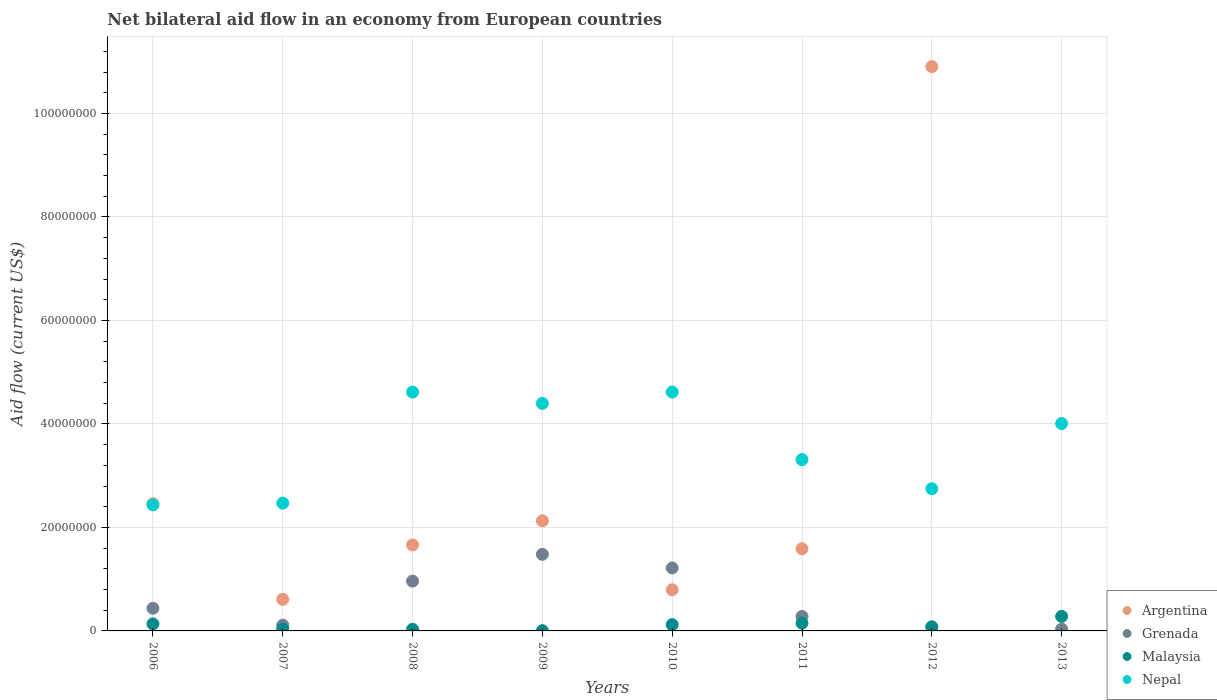Is the number of dotlines equal to the number of legend labels?
Your response must be concise. No. What is the net bilateral aid flow in Malaysia in 2013?
Keep it short and to the point. 2.81e+06. Across all years, what is the maximum net bilateral aid flow in Malaysia?
Ensure brevity in your answer.  2.81e+06. Across all years, what is the minimum net bilateral aid flow in Malaysia?
Keep it short and to the point. 5.00e+04. What is the total net bilateral aid flow in Malaysia in the graph?
Make the answer very short. 8.37e+06. What is the difference between the net bilateral aid flow in Nepal in 2007 and that in 2010?
Your answer should be very brief. -2.15e+07. What is the difference between the net bilateral aid flow in Malaysia in 2013 and the net bilateral aid flow in Argentina in 2007?
Keep it short and to the point. -3.29e+06. What is the average net bilateral aid flow in Argentina per year?
Provide a succinct answer. 2.52e+07. In the year 2010, what is the difference between the net bilateral aid flow in Grenada and net bilateral aid flow in Argentina?
Ensure brevity in your answer.  4.21e+06. In how many years, is the net bilateral aid flow in Grenada greater than 64000000 US$?
Your answer should be very brief. 0. What is the ratio of the net bilateral aid flow in Malaysia in 2008 to that in 2012?
Provide a short and direct response. 0.41. What is the difference between the highest and the second highest net bilateral aid flow in Malaysia?
Offer a very short reply. 1.31e+06. What is the difference between the highest and the lowest net bilateral aid flow in Grenada?
Your answer should be very brief. 1.45e+07. In how many years, is the net bilateral aid flow in Nepal greater than the average net bilateral aid flow in Nepal taken over all years?
Offer a very short reply. 4. Is it the case that in every year, the sum of the net bilateral aid flow in Nepal and net bilateral aid flow in Argentina  is greater than the sum of net bilateral aid flow in Malaysia and net bilateral aid flow in Grenada?
Your answer should be very brief. No. Is it the case that in every year, the sum of the net bilateral aid flow in Nepal and net bilateral aid flow in Argentina  is greater than the net bilateral aid flow in Grenada?
Your answer should be compact. Yes. Does the net bilateral aid flow in Nepal monotonically increase over the years?
Ensure brevity in your answer.  No. Is the net bilateral aid flow in Nepal strictly less than the net bilateral aid flow in Argentina over the years?
Provide a short and direct response. No. How many dotlines are there?
Provide a short and direct response. 4. Are the values on the major ticks of Y-axis written in scientific E-notation?
Keep it short and to the point. No. Does the graph contain any zero values?
Keep it short and to the point. Yes. Where does the legend appear in the graph?
Your response must be concise. Bottom right. How are the legend labels stacked?
Offer a terse response. Vertical. What is the title of the graph?
Your response must be concise. Net bilateral aid flow in an economy from European countries. Does "Afghanistan" appear as one of the legend labels in the graph?
Provide a short and direct response. No. What is the Aid flow (current US$) of Argentina in 2006?
Your answer should be very brief. 2.46e+07. What is the Aid flow (current US$) of Grenada in 2006?
Provide a short and direct response. 4.38e+06. What is the Aid flow (current US$) of Malaysia in 2006?
Give a very brief answer. 1.36e+06. What is the Aid flow (current US$) in Nepal in 2006?
Your answer should be compact. 2.44e+07. What is the Aid flow (current US$) in Argentina in 2007?
Your response must be concise. 6.10e+06. What is the Aid flow (current US$) of Grenada in 2007?
Make the answer very short. 1.11e+06. What is the Aid flow (current US$) in Nepal in 2007?
Provide a succinct answer. 2.47e+07. What is the Aid flow (current US$) in Argentina in 2008?
Make the answer very short. 1.66e+07. What is the Aid flow (current US$) of Grenada in 2008?
Ensure brevity in your answer.  9.63e+06. What is the Aid flow (current US$) in Malaysia in 2008?
Give a very brief answer. 3.10e+05. What is the Aid flow (current US$) in Nepal in 2008?
Your response must be concise. 4.62e+07. What is the Aid flow (current US$) in Argentina in 2009?
Your answer should be very brief. 2.13e+07. What is the Aid flow (current US$) of Grenada in 2009?
Your response must be concise. 1.48e+07. What is the Aid flow (current US$) in Nepal in 2009?
Your answer should be compact. 4.40e+07. What is the Aid flow (current US$) in Argentina in 2010?
Make the answer very short. 7.96e+06. What is the Aid flow (current US$) of Grenada in 2010?
Ensure brevity in your answer.  1.22e+07. What is the Aid flow (current US$) in Malaysia in 2010?
Ensure brevity in your answer.  1.21e+06. What is the Aid flow (current US$) in Nepal in 2010?
Your answer should be very brief. 4.62e+07. What is the Aid flow (current US$) of Argentina in 2011?
Make the answer very short. 1.59e+07. What is the Aid flow (current US$) of Grenada in 2011?
Ensure brevity in your answer.  2.79e+06. What is the Aid flow (current US$) in Malaysia in 2011?
Provide a short and direct response. 1.50e+06. What is the Aid flow (current US$) in Nepal in 2011?
Keep it short and to the point. 3.31e+07. What is the Aid flow (current US$) of Argentina in 2012?
Your response must be concise. 1.09e+08. What is the Aid flow (current US$) of Grenada in 2012?
Offer a very short reply. 8.00e+05. What is the Aid flow (current US$) in Malaysia in 2012?
Offer a very short reply. 7.50e+05. What is the Aid flow (current US$) in Nepal in 2012?
Provide a succinct answer. 2.75e+07. What is the Aid flow (current US$) in Argentina in 2013?
Make the answer very short. 0. What is the Aid flow (current US$) in Grenada in 2013?
Ensure brevity in your answer.  3.40e+05. What is the Aid flow (current US$) in Malaysia in 2013?
Your answer should be compact. 2.81e+06. What is the Aid flow (current US$) in Nepal in 2013?
Provide a succinct answer. 4.01e+07. Across all years, what is the maximum Aid flow (current US$) of Argentina?
Keep it short and to the point. 1.09e+08. Across all years, what is the maximum Aid flow (current US$) in Grenada?
Your response must be concise. 1.48e+07. Across all years, what is the maximum Aid flow (current US$) of Malaysia?
Give a very brief answer. 2.81e+06. Across all years, what is the maximum Aid flow (current US$) of Nepal?
Give a very brief answer. 4.62e+07. Across all years, what is the minimum Aid flow (current US$) in Grenada?
Provide a succinct answer. 3.40e+05. Across all years, what is the minimum Aid flow (current US$) in Nepal?
Provide a short and direct response. 2.44e+07. What is the total Aid flow (current US$) of Argentina in the graph?
Offer a terse response. 2.01e+08. What is the total Aid flow (current US$) of Grenada in the graph?
Provide a short and direct response. 4.60e+07. What is the total Aid flow (current US$) of Malaysia in the graph?
Keep it short and to the point. 8.37e+06. What is the total Aid flow (current US$) of Nepal in the graph?
Your response must be concise. 2.86e+08. What is the difference between the Aid flow (current US$) of Argentina in 2006 and that in 2007?
Keep it short and to the point. 1.85e+07. What is the difference between the Aid flow (current US$) in Grenada in 2006 and that in 2007?
Offer a terse response. 3.27e+06. What is the difference between the Aid flow (current US$) of Malaysia in 2006 and that in 2007?
Provide a short and direct response. 9.80e+05. What is the difference between the Aid flow (current US$) of Nepal in 2006 and that in 2007?
Your answer should be very brief. -3.30e+05. What is the difference between the Aid flow (current US$) in Argentina in 2006 and that in 2008?
Your response must be concise. 7.97e+06. What is the difference between the Aid flow (current US$) of Grenada in 2006 and that in 2008?
Make the answer very short. -5.25e+06. What is the difference between the Aid flow (current US$) in Malaysia in 2006 and that in 2008?
Offer a terse response. 1.05e+06. What is the difference between the Aid flow (current US$) in Nepal in 2006 and that in 2008?
Your answer should be very brief. -2.18e+07. What is the difference between the Aid flow (current US$) of Argentina in 2006 and that in 2009?
Your response must be concise. 3.30e+06. What is the difference between the Aid flow (current US$) in Grenada in 2006 and that in 2009?
Make the answer very short. -1.04e+07. What is the difference between the Aid flow (current US$) in Malaysia in 2006 and that in 2009?
Give a very brief answer. 1.31e+06. What is the difference between the Aid flow (current US$) of Nepal in 2006 and that in 2009?
Your answer should be compact. -1.96e+07. What is the difference between the Aid flow (current US$) in Argentina in 2006 and that in 2010?
Offer a very short reply. 1.66e+07. What is the difference between the Aid flow (current US$) of Grenada in 2006 and that in 2010?
Your answer should be very brief. -7.79e+06. What is the difference between the Aid flow (current US$) of Malaysia in 2006 and that in 2010?
Ensure brevity in your answer.  1.50e+05. What is the difference between the Aid flow (current US$) of Nepal in 2006 and that in 2010?
Your response must be concise. -2.18e+07. What is the difference between the Aid flow (current US$) in Argentina in 2006 and that in 2011?
Ensure brevity in your answer.  8.70e+06. What is the difference between the Aid flow (current US$) in Grenada in 2006 and that in 2011?
Offer a terse response. 1.59e+06. What is the difference between the Aid flow (current US$) in Nepal in 2006 and that in 2011?
Make the answer very short. -8.74e+06. What is the difference between the Aid flow (current US$) of Argentina in 2006 and that in 2012?
Give a very brief answer. -8.45e+07. What is the difference between the Aid flow (current US$) in Grenada in 2006 and that in 2012?
Provide a short and direct response. 3.58e+06. What is the difference between the Aid flow (current US$) in Nepal in 2006 and that in 2012?
Offer a terse response. -3.11e+06. What is the difference between the Aid flow (current US$) in Grenada in 2006 and that in 2013?
Your answer should be very brief. 4.04e+06. What is the difference between the Aid flow (current US$) in Malaysia in 2006 and that in 2013?
Your response must be concise. -1.45e+06. What is the difference between the Aid flow (current US$) of Nepal in 2006 and that in 2013?
Your response must be concise. -1.57e+07. What is the difference between the Aid flow (current US$) in Argentina in 2007 and that in 2008?
Make the answer very short. -1.05e+07. What is the difference between the Aid flow (current US$) in Grenada in 2007 and that in 2008?
Offer a very short reply. -8.52e+06. What is the difference between the Aid flow (current US$) of Nepal in 2007 and that in 2008?
Offer a terse response. -2.15e+07. What is the difference between the Aid flow (current US$) of Argentina in 2007 and that in 2009?
Your answer should be very brief. -1.52e+07. What is the difference between the Aid flow (current US$) of Grenada in 2007 and that in 2009?
Your response must be concise. -1.37e+07. What is the difference between the Aid flow (current US$) of Nepal in 2007 and that in 2009?
Provide a succinct answer. -1.93e+07. What is the difference between the Aid flow (current US$) of Argentina in 2007 and that in 2010?
Provide a succinct answer. -1.86e+06. What is the difference between the Aid flow (current US$) in Grenada in 2007 and that in 2010?
Provide a short and direct response. -1.11e+07. What is the difference between the Aid flow (current US$) in Malaysia in 2007 and that in 2010?
Give a very brief answer. -8.30e+05. What is the difference between the Aid flow (current US$) in Nepal in 2007 and that in 2010?
Your answer should be very brief. -2.15e+07. What is the difference between the Aid flow (current US$) in Argentina in 2007 and that in 2011?
Make the answer very short. -9.78e+06. What is the difference between the Aid flow (current US$) of Grenada in 2007 and that in 2011?
Your answer should be compact. -1.68e+06. What is the difference between the Aid flow (current US$) in Malaysia in 2007 and that in 2011?
Offer a very short reply. -1.12e+06. What is the difference between the Aid flow (current US$) in Nepal in 2007 and that in 2011?
Offer a terse response. -8.41e+06. What is the difference between the Aid flow (current US$) in Argentina in 2007 and that in 2012?
Offer a very short reply. -1.03e+08. What is the difference between the Aid flow (current US$) of Grenada in 2007 and that in 2012?
Your answer should be compact. 3.10e+05. What is the difference between the Aid flow (current US$) of Malaysia in 2007 and that in 2012?
Offer a terse response. -3.70e+05. What is the difference between the Aid flow (current US$) in Nepal in 2007 and that in 2012?
Keep it short and to the point. -2.78e+06. What is the difference between the Aid flow (current US$) in Grenada in 2007 and that in 2013?
Give a very brief answer. 7.70e+05. What is the difference between the Aid flow (current US$) of Malaysia in 2007 and that in 2013?
Ensure brevity in your answer.  -2.43e+06. What is the difference between the Aid flow (current US$) of Nepal in 2007 and that in 2013?
Ensure brevity in your answer.  -1.54e+07. What is the difference between the Aid flow (current US$) in Argentina in 2008 and that in 2009?
Your answer should be very brief. -4.67e+06. What is the difference between the Aid flow (current US$) in Grenada in 2008 and that in 2009?
Offer a very short reply. -5.17e+06. What is the difference between the Aid flow (current US$) in Malaysia in 2008 and that in 2009?
Provide a succinct answer. 2.60e+05. What is the difference between the Aid flow (current US$) in Nepal in 2008 and that in 2009?
Your response must be concise. 2.18e+06. What is the difference between the Aid flow (current US$) in Argentina in 2008 and that in 2010?
Your answer should be very brief. 8.65e+06. What is the difference between the Aid flow (current US$) in Grenada in 2008 and that in 2010?
Give a very brief answer. -2.54e+06. What is the difference between the Aid flow (current US$) in Malaysia in 2008 and that in 2010?
Keep it short and to the point. -9.00e+05. What is the difference between the Aid flow (current US$) in Nepal in 2008 and that in 2010?
Keep it short and to the point. 0. What is the difference between the Aid flow (current US$) of Argentina in 2008 and that in 2011?
Provide a succinct answer. 7.30e+05. What is the difference between the Aid flow (current US$) of Grenada in 2008 and that in 2011?
Your answer should be very brief. 6.84e+06. What is the difference between the Aid flow (current US$) of Malaysia in 2008 and that in 2011?
Provide a short and direct response. -1.19e+06. What is the difference between the Aid flow (current US$) in Nepal in 2008 and that in 2011?
Offer a terse response. 1.30e+07. What is the difference between the Aid flow (current US$) of Argentina in 2008 and that in 2012?
Your answer should be very brief. -9.24e+07. What is the difference between the Aid flow (current US$) in Grenada in 2008 and that in 2012?
Give a very brief answer. 8.83e+06. What is the difference between the Aid flow (current US$) in Malaysia in 2008 and that in 2012?
Provide a succinct answer. -4.40e+05. What is the difference between the Aid flow (current US$) of Nepal in 2008 and that in 2012?
Ensure brevity in your answer.  1.87e+07. What is the difference between the Aid flow (current US$) of Grenada in 2008 and that in 2013?
Your answer should be compact. 9.29e+06. What is the difference between the Aid flow (current US$) of Malaysia in 2008 and that in 2013?
Your response must be concise. -2.50e+06. What is the difference between the Aid flow (current US$) of Nepal in 2008 and that in 2013?
Ensure brevity in your answer.  6.08e+06. What is the difference between the Aid flow (current US$) in Argentina in 2009 and that in 2010?
Your answer should be very brief. 1.33e+07. What is the difference between the Aid flow (current US$) in Grenada in 2009 and that in 2010?
Your response must be concise. 2.63e+06. What is the difference between the Aid flow (current US$) in Malaysia in 2009 and that in 2010?
Your response must be concise. -1.16e+06. What is the difference between the Aid flow (current US$) of Nepal in 2009 and that in 2010?
Make the answer very short. -2.18e+06. What is the difference between the Aid flow (current US$) of Argentina in 2009 and that in 2011?
Your answer should be compact. 5.40e+06. What is the difference between the Aid flow (current US$) of Grenada in 2009 and that in 2011?
Offer a very short reply. 1.20e+07. What is the difference between the Aid flow (current US$) in Malaysia in 2009 and that in 2011?
Your answer should be compact. -1.45e+06. What is the difference between the Aid flow (current US$) of Nepal in 2009 and that in 2011?
Your answer should be compact. 1.09e+07. What is the difference between the Aid flow (current US$) in Argentina in 2009 and that in 2012?
Offer a very short reply. -8.78e+07. What is the difference between the Aid flow (current US$) in Grenada in 2009 and that in 2012?
Give a very brief answer. 1.40e+07. What is the difference between the Aid flow (current US$) of Malaysia in 2009 and that in 2012?
Provide a succinct answer. -7.00e+05. What is the difference between the Aid flow (current US$) of Nepal in 2009 and that in 2012?
Provide a short and direct response. 1.65e+07. What is the difference between the Aid flow (current US$) in Grenada in 2009 and that in 2013?
Ensure brevity in your answer.  1.45e+07. What is the difference between the Aid flow (current US$) in Malaysia in 2009 and that in 2013?
Your answer should be very brief. -2.76e+06. What is the difference between the Aid flow (current US$) in Nepal in 2009 and that in 2013?
Offer a very short reply. 3.90e+06. What is the difference between the Aid flow (current US$) of Argentina in 2010 and that in 2011?
Provide a succinct answer. -7.92e+06. What is the difference between the Aid flow (current US$) in Grenada in 2010 and that in 2011?
Make the answer very short. 9.38e+06. What is the difference between the Aid flow (current US$) in Nepal in 2010 and that in 2011?
Offer a very short reply. 1.30e+07. What is the difference between the Aid flow (current US$) in Argentina in 2010 and that in 2012?
Provide a short and direct response. -1.01e+08. What is the difference between the Aid flow (current US$) in Grenada in 2010 and that in 2012?
Offer a terse response. 1.14e+07. What is the difference between the Aid flow (current US$) in Nepal in 2010 and that in 2012?
Keep it short and to the point. 1.87e+07. What is the difference between the Aid flow (current US$) of Grenada in 2010 and that in 2013?
Keep it short and to the point. 1.18e+07. What is the difference between the Aid flow (current US$) in Malaysia in 2010 and that in 2013?
Your answer should be compact. -1.60e+06. What is the difference between the Aid flow (current US$) of Nepal in 2010 and that in 2013?
Give a very brief answer. 6.08e+06. What is the difference between the Aid flow (current US$) in Argentina in 2011 and that in 2012?
Offer a very short reply. -9.32e+07. What is the difference between the Aid flow (current US$) of Grenada in 2011 and that in 2012?
Make the answer very short. 1.99e+06. What is the difference between the Aid flow (current US$) in Malaysia in 2011 and that in 2012?
Keep it short and to the point. 7.50e+05. What is the difference between the Aid flow (current US$) of Nepal in 2011 and that in 2012?
Provide a succinct answer. 5.63e+06. What is the difference between the Aid flow (current US$) in Grenada in 2011 and that in 2013?
Offer a very short reply. 2.45e+06. What is the difference between the Aid flow (current US$) of Malaysia in 2011 and that in 2013?
Give a very brief answer. -1.31e+06. What is the difference between the Aid flow (current US$) in Nepal in 2011 and that in 2013?
Give a very brief answer. -6.97e+06. What is the difference between the Aid flow (current US$) in Grenada in 2012 and that in 2013?
Your answer should be compact. 4.60e+05. What is the difference between the Aid flow (current US$) of Malaysia in 2012 and that in 2013?
Provide a succinct answer. -2.06e+06. What is the difference between the Aid flow (current US$) in Nepal in 2012 and that in 2013?
Your answer should be very brief. -1.26e+07. What is the difference between the Aid flow (current US$) in Argentina in 2006 and the Aid flow (current US$) in Grenada in 2007?
Offer a very short reply. 2.35e+07. What is the difference between the Aid flow (current US$) in Argentina in 2006 and the Aid flow (current US$) in Malaysia in 2007?
Give a very brief answer. 2.42e+07. What is the difference between the Aid flow (current US$) in Grenada in 2006 and the Aid flow (current US$) in Nepal in 2007?
Provide a succinct answer. -2.03e+07. What is the difference between the Aid flow (current US$) in Malaysia in 2006 and the Aid flow (current US$) in Nepal in 2007?
Your response must be concise. -2.33e+07. What is the difference between the Aid flow (current US$) of Argentina in 2006 and the Aid flow (current US$) of Grenada in 2008?
Keep it short and to the point. 1.50e+07. What is the difference between the Aid flow (current US$) in Argentina in 2006 and the Aid flow (current US$) in Malaysia in 2008?
Offer a terse response. 2.43e+07. What is the difference between the Aid flow (current US$) of Argentina in 2006 and the Aid flow (current US$) of Nepal in 2008?
Make the answer very short. -2.16e+07. What is the difference between the Aid flow (current US$) of Grenada in 2006 and the Aid flow (current US$) of Malaysia in 2008?
Your answer should be compact. 4.07e+06. What is the difference between the Aid flow (current US$) in Grenada in 2006 and the Aid flow (current US$) in Nepal in 2008?
Give a very brief answer. -4.18e+07. What is the difference between the Aid flow (current US$) in Malaysia in 2006 and the Aid flow (current US$) in Nepal in 2008?
Keep it short and to the point. -4.48e+07. What is the difference between the Aid flow (current US$) of Argentina in 2006 and the Aid flow (current US$) of Grenada in 2009?
Provide a succinct answer. 9.78e+06. What is the difference between the Aid flow (current US$) in Argentina in 2006 and the Aid flow (current US$) in Malaysia in 2009?
Offer a terse response. 2.45e+07. What is the difference between the Aid flow (current US$) in Argentina in 2006 and the Aid flow (current US$) in Nepal in 2009?
Your response must be concise. -1.94e+07. What is the difference between the Aid flow (current US$) of Grenada in 2006 and the Aid flow (current US$) of Malaysia in 2009?
Provide a succinct answer. 4.33e+06. What is the difference between the Aid flow (current US$) in Grenada in 2006 and the Aid flow (current US$) in Nepal in 2009?
Your response must be concise. -3.96e+07. What is the difference between the Aid flow (current US$) in Malaysia in 2006 and the Aid flow (current US$) in Nepal in 2009?
Your response must be concise. -4.26e+07. What is the difference between the Aid flow (current US$) in Argentina in 2006 and the Aid flow (current US$) in Grenada in 2010?
Provide a short and direct response. 1.24e+07. What is the difference between the Aid flow (current US$) in Argentina in 2006 and the Aid flow (current US$) in Malaysia in 2010?
Provide a succinct answer. 2.34e+07. What is the difference between the Aid flow (current US$) in Argentina in 2006 and the Aid flow (current US$) in Nepal in 2010?
Provide a short and direct response. -2.16e+07. What is the difference between the Aid flow (current US$) of Grenada in 2006 and the Aid flow (current US$) of Malaysia in 2010?
Offer a very short reply. 3.17e+06. What is the difference between the Aid flow (current US$) of Grenada in 2006 and the Aid flow (current US$) of Nepal in 2010?
Offer a very short reply. -4.18e+07. What is the difference between the Aid flow (current US$) of Malaysia in 2006 and the Aid flow (current US$) of Nepal in 2010?
Make the answer very short. -4.48e+07. What is the difference between the Aid flow (current US$) in Argentina in 2006 and the Aid flow (current US$) in Grenada in 2011?
Provide a succinct answer. 2.18e+07. What is the difference between the Aid flow (current US$) of Argentina in 2006 and the Aid flow (current US$) of Malaysia in 2011?
Provide a short and direct response. 2.31e+07. What is the difference between the Aid flow (current US$) of Argentina in 2006 and the Aid flow (current US$) of Nepal in 2011?
Make the answer very short. -8.53e+06. What is the difference between the Aid flow (current US$) in Grenada in 2006 and the Aid flow (current US$) in Malaysia in 2011?
Provide a short and direct response. 2.88e+06. What is the difference between the Aid flow (current US$) of Grenada in 2006 and the Aid flow (current US$) of Nepal in 2011?
Keep it short and to the point. -2.87e+07. What is the difference between the Aid flow (current US$) of Malaysia in 2006 and the Aid flow (current US$) of Nepal in 2011?
Your answer should be compact. -3.18e+07. What is the difference between the Aid flow (current US$) in Argentina in 2006 and the Aid flow (current US$) in Grenada in 2012?
Ensure brevity in your answer.  2.38e+07. What is the difference between the Aid flow (current US$) in Argentina in 2006 and the Aid flow (current US$) in Malaysia in 2012?
Your response must be concise. 2.38e+07. What is the difference between the Aid flow (current US$) of Argentina in 2006 and the Aid flow (current US$) of Nepal in 2012?
Provide a short and direct response. -2.90e+06. What is the difference between the Aid flow (current US$) of Grenada in 2006 and the Aid flow (current US$) of Malaysia in 2012?
Provide a short and direct response. 3.63e+06. What is the difference between the Aid flow (current US$) of Grenada in 2006 and the Aid flow (current US$) of Nepal in 2012?
Your response must be concise. -2.31e+07. What is the difference between the Aid flow (current US$) in Malaysia in 2006 and the Aid flow (current US$) in Nepal in 2012?
Ensure brevity in your answer.  -2.61e+07. What is the difference between the Aid flow (current US$) in Argentina in 2006 and the Aid flow (current US$) in Grenada in 2013?
Your response must be concise. 2.42e+07. What is the difference between the Aid flow (current US$) of Argentina in 2006 and the Aid flow (current US$) of Malaysia in 2013?
Your answer should be compact. 2.18e+07. What is the difference between the Aid flow (current US$) of Argentina in 2006 and the Aid flow (current US$) of Nepal in 2013?
Provide a succinct answer. -1.55e+07. What is the difference between the Aid flow (current US$) of Grenada in 2006 and the Aid flow (current US$) of Malaysia in 2013?
Keep it short and to the point. 1.57e+06. What is the difference between the Aid flow (current US$) of Grenada in 2006 and the Aid flow (current US$) of Nepal in 2013?
Provide a short and direct response. -3.57e+07. What is the difference between the Aid flow (current US$) in Malaysia in 2006 and the Aid flow (current US$) in Nepal in 2013?
Give a very brief answer. -3.87e+07. What is the difference between the Aid flow (current US$) of Argentina in 2007 and the Aid flow (current US$) of Grenada in 2008?
Provide a short and direct response. -3.53e+06. What is the difference between the Aid flow (current US$) of Argentina in 2007 and the Aid flow (current US$) of Malaysia in 2008?
Give a very brief answer. 5.79e+06. What is the difference between the Aid flow (current US$) in Argentina in 2007 and the Aid flow (current US$) in Nepal in 2008?
Provide a succinct answer. -4.01e+07. What is the difference between the Aid flow (current US$) in Grenada in 2007 and the Aid flow (current US$) in Nepal in 2008?
Provide a short and direct response. -4.50e+07. What is the difference between the Aid flow (current US$) of Malaysia in 2007 and the Aid flow (current US$) of Nepal in 2008?
Make the answer very short. -4.58e+07. What is the difference between the Aid flow (current US$) of Argentina in 2007 and the Aid flow (current US$) of Grenada in 2009?
Offer a terse response. -8.70e+06. What is the difference between the Aid flow (current US$) of Argentina in 2007 and the Aid flow (current US$) of Malaysia in 2009?
Offer a terse response. 6.05e+06. What is the difference between the Aid flow (current US$) in Argentina in 2007 and the Aid flow (current US$) in Nepal in 2009?
Provide a succinct answer. -3.79e+07. What is the difference between the Aid flow (current US$) in Grenada in 2007 and the Aid flow (current US$) in Malaysia in 2009?
Keep it short and to the point. 1.06e+06. What is the difference between the Aid flow (current US$) of Grenada in 2007 and the Aid flow (current US$) of Nepal in 2009?
Your response must be concise. -4.29e+07. What is the difference between the Aid flow (current US$) in Malaysia in 2007 and the Aid flow (current US$) in Nepal in 2009?
Make the answer very short. -4.36e+07. What is the difference between the Aid flow (current US$) in Argentina in 2007 and the Aid flow (current US$) in Grenada in 2010?
Give a very brief answer. -6.07e+06. What is the difference between the Aid flow (current US$) of Argentina in 2007 and the Aid flow (current US$) of Malaysia in 2010?
Give a very brief answer. 4.89e+06. What is the difference between the Aid flow (current US$) of Argentina in 2007 and the Aid flow (current US$) of Nepal in 2010?
Make the answer very short. -4.01e+07. What is the difference between the Aid flow (current US$) in Grenada in 2007 and the Aid flow (current US$) in Malaysia in 2010?
Provide a short and direct response. -1.00e+05. What is the difference between the Aid flow (current US$) of Grenada in 2007 and the Aid flow (current US$) of Nepal in 2010?
Provide a short and direct response. -4.50e+07. What is the difference between the Aid flow (current US$) of Malaysia in 2007 and the Aid flow (current US$) of Nepal in 2010?
Offer a very short reply. -4.58e+07. What is the difference between the Aid flow (current US$) in Argentina in 2007 and the Aid flow (current US$) in Grenada in 2011?
Give a very brief answer. 3.31e+06. What is the difference between the Aid flow (current US$) of Argentina in 2007 and the Aid flow (current US$) of Malaysia in 2011?
Your response must be concise. 4.60e+06. What is the difference between the Aid flow (current US$) in Argentina in 2007 and the Aid flow (current US$) in Nepal in 2011?
Your response must be concise. -2.70e+07. What is the difference between the Aid flow (current US$) in Grenada in 2007 and the Aid flow (current US$) in Malaysia in 2011?
Offer a terse response. -3.90e+05. What is the difference between the Aid flow (current US$) in Grenada in 2007 and the Aid flow (current US$) in Nepal in 2011?
Make the answer very short. -3.20e+07. What is the difference between the Aid flow (current US$) of Malaysia in 2007 and the Aid flow (current US$) of Nepal in 2011?
Make the answer very short. -3.27e+07. What is the difference between the Aid flow (current US$) of Argentina in 2007 and the Aid flow (current US$) of Grenada in 2012?
Your answer should be very brief. 5.30e+06. What is the difference between the Aid flow (current US$) in Argentina in 2007 and the Aid flow (current US$) in Malaysia in 2012?
Ensure brevity in your answer.  5.35e+06. What is the difference between the Aid flow (current US$) of Argentina in 2007 and the Aid flow (current US$) of Nepal in 2012?
Offer a terse response. -2.14e+07. What is the difference between the Aid flow (current US$) of Grenada in 2007 and the Aid flow (current US$) of Malaysia in 2012?
Make the answer very short. 3.60e+05. What is the difference between the Aid flow (current US$) in Grenada in 2007 and the Aid flow (current US$) in Nepal in 2012?
Offer a terse response. -2.64e+07. What is the difference between the Aid flow (current US$) of Malaysia in 2007 and the Aid flow (current US$) of Nepal in 2012?
Provide a succinct answer. -2.71e+07. What is the difference between the Aid flow (current US$) in Argentina in 2007 and the Aid flow (current US$) in Grenada in 2013?
Offer a terse response. 5.76e+06. What is the difference between the Aid flow (current US$) of Argentina in 2007 and the Aid flow (current US$) of Malaysia in 2013?
Offer a terse response. 3.29e+06. What is the difference between the Aid flow (current US$) of Argentina in 2007 and the Aid flow (current US$) of Nepal in 2013?
Offer a terse response. -3.40e+07. What is the difference between the Aid flow (current US$) in Grenada in 2007 and the Aid flow (current US$) in Malaysia in 2013?
Give a very brief answer. -1.70e+06. What is the difference between the Aid flow (current US$) in Grenada in 2007 and the Aid flow (current US$) in Nepal in 2013?
Provide a short and direct response. -3.90e+07. What is the difference between the Aid flow (current US$) of Malaysia in 2007 and the Aid flow (current US$) of Nepal in 2013?
Offer a very short reply. -3.97e+07. What is the difference between the Aid flow (current US$) of Argentina in 2008 and the Aid flow (current US$) of Grenada in 2009?
Make the answer very short. 1.81e+06. What is the difference between the Aid flow (current US$) of Argentina in 2008 and the Aid flow (current US$) of Malaysia in 2009?
Give a very brief answer. 1.66e+07. What is the difference between the Aid flow (current US$) of Argentina in 2008 and the Aid flow (current US$) of Nepal in 2009?
Your answer should be compact. -2.74e+07. What is the difference between the Aid flow (current US$) of Grenada in 2008 and the Aid flow (current US$) of Malaysia in 2009?
Offer a very short reply. 9.58e+06. What is the difference between the Aid flow (current US$) of Grenada in 2008 and the Aid flow (current US$) of Nepal in 2009?
Keep it short and to the point. -3.44e+07. What is the difference between the Aid flow (current US$) of Malaysia in 2008 and the Aid flow (current US$) of Nepal in 2009?
Provide a succinct answer. -4.37e+07. What is the difference between the Aid flow (current US$) in Argentina in 2008 and the Aid flow (current US$) in Grenada in 2010?
Provide a short and direct response. 4.44e+06. What is the difference between the Aid flow (current US$) in Argentina in 2008 and the Aid flow (current US$) in Malaysia in 2010?
Ensure brevity in your answer.  1.54e+07. What is the difference between the Aid flow (current US$) of Argentina in 2008 and the Aid flow (current US$) of Nepal in 2010?
Provide a succinct answer. -2.96e+07. What is the difference between the Aid flow (current US$) of Grenada in 2008 and the Aid flow (current US$) of Malaysia in 2010?
Your answer should be compact. 8.42e+06. What is the difference between the Aid flow (current US$) of Grenada in 2008 and the Aid flow (current US$) of Nepal in 2010?
Offer a terse response. -3.65e+07. What is the difference between the Aid flow (current US$) of Malaysia in 2008 and the Aid flow (current US$) of Nepal in 2010?
Your answer should be compact. -4.58e+07. What is the difference between the Aid flow (current US$) in Argentina in 2008 and the Aid flow (current US$) in Grenada in 2011?
Keep it short and to the point. 1.38e+07. What is the difference between the Aid flow (current US$) in Argentina in 2008 and the Aid flow (current US$) in Malaysia in 2011?
Offer a very short reply. 1.51e+07. What is the difference between the Aid flow (current US$) in Argentina in 2008 and the Aid flow (current US$) in Nepal in 2011?
Your answer should be very brief. -1.65e+07. What is the difference between the Aid flow (current US$) in Grenada in 2008 and the Aid flow (current US$) in Malaysia in 2011?
Provide a succinct answer. 8.13e+06. What is the difference between the Aid flow (current US$) in Grenada in 2008 and the Aid flow (current US$) in Nepal in 2011?
Offer a terse response. -2.35e+07. What is the difference between the Aid flow (current US$) of Malaysia in 2008 and the Aid flow (current US$) of Nepal in 2011?
Offer a terse response. -3.28e+07. What is the difference between the Aid flow (current US$) of Argentina in 2008 and the Aid flow (current US$) of Grenada in 2012?
Provide a short and direct response. 1.58e+07. What is the difference between the Aid flow (current US$) in Argentina in 2008 and the Aid flow (current US$) in Malaysia in 2012?
Your response must be concise. 1.59e+07. What is the difference between the Aid flow (current US$) in Argentina in 2008 and the Aid flow (current US$) in Nepal in 2012?
Provide a short and direct response. -1.09e+07. What is the difference between the Aid flow (current US$) of Grenada in 2008 and the Aid flow (current US$) of Malaysia in 2012?
Ensure brevity in your answer.  8.88e+06. What is the difference between the Aid flow (current US$) in Grenada in 2008 and the Aid flow (current US$) in Nepal in 2012?
Make the answer very short. -1.78e+07. What is the difference between the Aid flow (current US$) in Malaysia in 2008 and the Aid flow (current US$) in Nepal in 2012?
Your answer should be very brief. -2.72e+07. What is the difference between the Aid flow (current US$) in Argentina in 2008 and the Aid flow (current US$) in Grenada in 2013?
Offer a terse response. 1.63e+07. What is the difference between the Aid flow (current US$) of Argentina in 2008 and the Aid flow (current US$) of Malaysia in 2013?
Offer a terse response. 1.38e+07. What is the difference between the Aid flow (current US$) of Argentina in 2008 and the Aid flow (current US$) of Nepal in 2013?
Your answer should be compact. -2.35e+07. What is the difference between the Aid flow (current US$) of Grenada in 2008 and the Aid flow (current US$) of Malaysia in 2013?
Ensure brevity in your answer.  6.82e+06. What is the difference between the Aid flow (current US$) in Grenada in 2008 and the Aid flow (current US$) in Nepal in 2013?
Give a very brief answer. -3.04e+07. What is the difference between the Aid flow (current US$) of Malaysia in 2008 and the Aid flow (current US$) of Nepal in 2013?
Your answer should be compact. -3.98e+07. What is the difference between the Aid flow (current US$) in Argentina in 2009 and the Aid flow (current US$) in Grenada in 2010?
Your answer should be very brief. 9.11e+06. What is the difference between the Aid flow (current US$) in Argentina in 2009 and the Aid flow (current US$) in Malaysia in 2010?
Provide a succinct answer. 2.01e+07. What is the difference between the Aid flow (current US$) in Argentina in 2009 and the Aid flow (current US$) in Nepal in 2010?
Make the answer very short. -2.49e+07. What is the difference between the Aid flow (current US$) in Grenada in 2009 and the Aid flow (current US$) in Malaysia in 2010?
Your answer should be very brief. 1.36e+07. What is the difference between the Aid flow (current US$) of Grenada in 2009 and the Aid flow (current US$) of Nepal in 2010?
Provide a short and direct response. -3.14e+07. What is the difference between the Aid flow (current US$) in Malaysia in 2009 and the Aid flow (current US$) in Nepal in 2010?
Provide a succinct answer. -4.61e+07. What is the difference between the Aid flow (current US$) in Argentina in 2009 and the Aid flow (current US$) in Grenada in 2011?
Keep it short and to the point. 1.85e+07. What is the difference between the Aid flow (current US$) of Argentina in 2009 and the Aid flow (current US$) of Malaysia in 2011?
Your response must be concise. 1.98e+07. What is the difference between the Aid flow (current US$) in Argentina in 2009 and the Aid flow (current US$) in Nepal in 2011?
Keep it short and to the point. -1.18e+07. What is the difference between the Aid flow (current US$) in Grenada in 2009 and the Aid flow (current US$) in Malaysia in 2011?
Offer a very short reply. 1.33e+07. What is the difference between the Aid flow (current US$) of Grenada in 2009 and the Aid flow (current US$) of Nepal in 2011?
Offer a terse response. -1.83e+07. What is the difference between the Aid flow (current US$) in Malaysia in 2009 and the Aid flow (current US$) in Nepal in 2011?
Make the answer very short. -3.31e+07. What is the difference between the Aid flow (current US$) in Argentina in 2009 and the Aid flow (current US$) in Grenada in 2012?
Ensure brevity in your answer.  2.05e+07. What is the difference between the Aid flow (current US$) in Argentina in 2009 and the Aid flow (current US$) in Malaysia in 2012?
Your response must be concise. 2.05e+07. What is the difference between the Aid flow (current US$) of Argentina in 2009 and the Aid flow (current US$) of Nepal in 2012?
Give a very brief answer. -6.20e+06. What is the difference between the Aid flow (current US$) of Grenada in 2009 and the Aid flow (current US$) of Malaysia in 2012?
Your response must be concise. 1.40e+07. What is the difference between the Aid flow (current US$) in Grenada in 2009 and the Aid flow (current US$) in Nepal in 2012?
Make the answer very short. -1.27e+07. What is the difference between the Aid flow (current US$) of Malaysia in 2009 and the Aid flow (current US$) of Nepal in 2012?
Your response must be concise. -2.74e+07. What is the difference between the Aid flow (current US$) in Argentina in 2009 and the Aid flow (current US$) in Grenada in 2013?
Provide a succinct answer. 2.09e+07. What is the difference between the Aid flow (current US$) of Argentina in 2009 and the Aid flow (current US$) of Malaysia in 2013?
Provide a succinct answer. 1.85e+07. What is the difference between the Aid flow (current US$) in Argentina in 2009 and the Aid flow (current US$) in Nepal in 2013?
Keep it short and to the point. -1.88e+07. What is the difference between the Aid flow (current US$) in Grenada in 2009 and the Aid flow (current US$) in Malaysia in 2013?
Offer a terse response. 1.20e+07. What is the difference between the Aid flow (current US$) in Grenada in 2009 and the Aid flow (current US$) in Nepal in 2013?
Provide a short and direct response. -2.53e+07. What is the difference between the Aid flow (current US$) of Malaysia in 2009 and the Aid flow (current US$) of Nepal in 2013?
Ensure brevity in your answer.  -4.00e+07. What is the difference between the Aid flow (current US$) of Argentina in 2010 and the Aid flow (current US$) of Grenada in 2011?
Ensure brevity in your answer.  5.17e+06. What is the difference between the Aid flow (current US$) in Argentina in 2010 and the Aid flow (current US$) in Malaysia in 2011?
Your answer should be very brief. 6.46e+06. What is the difference between the Aid flow (current US$) of Argentina in 2010 and the Aid flow (current US$) of Nepal in 2011?
Offer a terse response. -2.52e+07. What is the difference between the Aid flow (current US$) of Grenada in 2010 and the Aid flow (current US$) of Malaysia in 2011?
Ensure brevity in your answer.  1.07e+07. What is the difference between the Aid flow (current US$) in Grenada in 2010 and the Aid flow (current US$) in Nepal in 2011?
Your response must be concise. -2.09e+07. What is the difference between the Aid flow (current US$) in Malaysia in 2010 and the Aid flow (current US$) in Nepal in 2011?
Provide a short and direct response. -3.19e+07. What is the difference between the Aid flow (current US$) of Argentina in 2010 and the Aid flow (current US$) of Grenada in 2012?
Provide a succinct answer. 7.16e+06. What is the difference between the Aid flow (current US$) in Argentina in 2010 and the Aid flow (current US$) in Malaysia in 2012?
Keep it short and to the point. 7.21e+06. What is the difference between the Aid flow (current US$) in Argentina in 2010 and the Aid flow (current US$) in Nepal in 2012?
Ensure brevity in your answer.  -1.95e+07. What is the difference between the Aid flow (current US$) in Grenada in 2010 and the Aid flow (current US$) in Malaysia in 2012?
Ensure brevity in your answer.  1.14e+07. What is the difference between the Aid flow (current US$) in Grenada in 2010 and the Aid flow (current US$) in Nepal in 2012?
Your response must be concise. -1.53e+07. What is the difference between the Aid flow (current US$) in Malaysia in 2010 and the Aid flow (current US$) in Nepal in 2012?
Provide a succinct answer. -2.63e+07. What is the difference between the Aid flow (current US$) in Argentina in 2010 and the Aid flow (current US$) in Grenada in 2013?
Ensure brevity in your answer.  7.62e+06. What is the difference between the Aid flow (current US$) of Argentina in 2010 and the Aid flow (current US$) of Malaysia in 2013?
Offer a terse response. 5.15e+06. What is the difference between the Aid flow (current US$) of Argentina in 2010 and the Aid flow (current US$) of Nepal in 2013?
Make the answer very short. -3.21e+07. What is the difference between the Aid flow (current US$) of Grenada in 2010 and the Aid flow (current US$) of Malaysia in 2013?
Provide a short and direct response. 9.36e+06. What is the difference between the Aid flow (current US$) in Grenada in 2010 and the Aid flow (current US$) in Nepal in 2013?
Provide a succinct answer. -2.79e+07. What is the difference between the Aid flow (current US$) in Malaysia in 2010 and the Aid flow (current US$) in Nepal in 2013?
Provide a short and direct response. -3.89e+07. What is the difference between the Aid flow (current US$) in Argentina in 2011 and the Aid flow (current US$) in Grenada in 2012?
Your response must be concise. 1.51e+07. What is the difference between the Aid flow (current US$) in Argentina in 2011 and the Aid flow (current US$) in Malaysia in 2012?
Provide a short and direct response. 1.51e+07. What is the difference between the Aid flow (current US$) in Argentina in 2011 and the Aid flow (current US$) in Nepal in 2012?
Make the answer very short. -1.16e+07. What is the difference between the Aid flow (current US$) of Grenada in 2011 and the Aid flow (current US$) of Malaysia in 2012?
Your response must be concise. 2.04e+06. What is the difference between the Aid flow (current US$) in Grenada in 2011 and the Aid flow (current US$) in Nepal in 2012?
Give a very brief answer. -2.47e+07. What is the difference between the Aid flow (current US$) in Malaysia in 2011 and the Aid flow (current US$) in Nepal in 2012?
Your answer should be very brief. -2.60e+07. What is the difference between the Aid flow (current US$) of Argentina in 2011 and the Aid flow (current US$) of Grenada in 2013?
Provide a succinct answer. 1.55e+07. What is the difference between the Aid flow (current US$) in Argentina in 2011 and the Aid flow (current US$) in Malaysia in 2013?
Your answer should be very brief. 1.31e+07. What is the difference between the Aid flow (current US$) of Argentina in 2011 and the Aid flow (current US$) of Nepal in 2013?
Make the answer very short. -2.42e+07. What is the difference between the Aid flow (current US$) of Grenada in 2011 and the Aid flow (current US$) of Malaysia in 2013?
Keep it short and to the point. -2.00e+04. What is the difference between the Aid flow (current US$) of Grenada in 2011 and the Aid flow (current US$) of Nepal in 2013?
Provide a succinct answer. -3.73e+07. What is the difference between the Aid flow (current US$) in Malaysia in 2011 and the Aid flow (current US$) in Nepal in 2013?
Ensure brevity in your answer.  -3.86e+07. What is the difference between the Aid flow (current US$) of Argentina in 2012 and the Aid flow (current US$) of Grenada in 2013?
Your response must be concise. 1.09e+08. What is the difference between the Aid flow (current US$) in Argentina in 2012 and the Aid flow (current US$) in Malaysia in 2013?
Your response must be concise. 1.06e+08. What is the difference between the Aid flow (current US$) of Argentina in 2012 and the Aid flow (current US$) of Nepal in 2013?
Provide a succinct answer. 6.90e+07. What is the difference between the Aid flow (current US$) in Grenada in 2012 and the Aid flow (current US$) in Malaysia in 2013?
Provide a succinct answer. -2.01e+06. What is the difference between the Aid flow (current US$) in Grenada in 2012 and the Aid flow (current US$) in Nepal in 2013?
Provide a succinct answer. -3.93e+07. What is the difference between the Aid flow (current US$) of Malaysia in 2012 and the Aid flow (current US$) of Nepal in 2013?
Provide a short and direct response. -3.93e+07. What is the average Aid flow (current US$) of Argentina per year?
Your answer should be very brief. 2.52e+07. What is the average Aid flow (current US$) of Grenada per year?
Provide a short and direct response. 5.75e+06. What is the average Aid flow (current US$) in Malaysia per year?
Make the answer very short. 1.05e+06. What is the average Aid flow (current US$) in Nepal per year?
Your answer should be very brief. 3.58e+07. In the year 2006, what is the difference between the Aid flow (current US$) of Argentina and Aid flow (current US$) of Grenada?
Your answer should be compact. 2.02e+07. In the year 2006, what is the difference between the Aid flow (current US$) in Argentina and Aid flow (current US$) in Malaysia?
Offer a terse response. 2.32e+07. In the year 2006, what is the difference between the Aid flow (current US$) in Argentina and Aid flow (current US$) in Nepal?
Your response must be concise. 2.10e+05. In the year 2006, what is the difference between the Aid flow (current US$) in Grenada and Aid flow (current US$) in Malaysia?
Give a very brief answer. 3.02e+06. In the year 2006, what is the difference between the Aid flow (current US$) in Grenada and Aid flow (current US$) in Nepal?
Your answer should be compact. -2.00e+07. In the year 2006, what is the difference between the Aid flow (current US$) of Malaysia and Aid flow (current US$) of Nepal?
Provide a short and direct response. -2.30e+07. In the year 2007, what is the difference between the Aid flow (current US$) in Argentina and Aid flow (current US$) in Grenada?
Your answer should be compact. 4.99e+06. In the year 2007, what is the difference between the Aid flow (current US$) in Argentina and Aid flow (current US$) in Malaysia?
Offer a very short reply. 5.72e+06. In the year 2007, what is the difference between the Aid flow (current US$) of Argentina and Aid flow (current US$) of Nepal?
Your answer should be compact. -1.86e+07. In the year 2007, what is the difference between the Aid flow (current US$) of Grenada and Aid flow (current US$) of Malaysia?
Your answer should be very brief. 7.30e+05. In the year 2007, what is the difference between the Aid flow (current US$) of Grenada and Aid flow (current US$) of Nepal?
Give a very brief answer. -2.36e+07. In the year 2007, what is the difference between the Aid flow (current US$) of Malaysia and Aid flow (current US$) of Nepal?
Keep it short and to the point. -2.43e+07. In the year 2008, what is the difference between the Aid flow (current US$) of Argentina and Aid flow (current US$) of Grenada?
Keep it short and to the point. 6.98e+06. In the year 2008, what is the difference between the Aid flow (current US$) in Argentina and Aid flow (current US$) in Malaysia?
Your answer should be compact. 1.63e+07. In the year 2008, what is the difference between the Aid flow (current US$) in Argentina and Aid flow (current US$) in Nepal?
Your response must be concise. -2.96e+07. In the year 2008, what is the difference between the Aid flow (current US$) in Grenada and Aid flow (current US$) in Malaysia?
Ensure brevity in your answer.  9.32e+06. In the year 2008, what is the difference between the Aid flow (current US$) in Grenada and Aid flow (current US$) in Nepal?
Offer a terse response. -3.65e+07. In the year 2008, what is the difference between the Aid flow (current US$) in Malaysia and Aid flow (current US$) in Nepal?
Your response must be concise. -4.58e+07. In the year 2009, what is the difference between the Aid flow (current US$) in Argentina and Aid flow (current US$) in Grenada?
Provide a succinct answer. 6.48e+06. In the year 2009, what is the difference between the Aid flow (current US$) of Argentina and Aid flow (current US$) of Malaysia?
Keep it short and to the point. 2.12e+07. In the year 2009, what is the difference between the Aid flow (current US$) in Argentina and Aid flow (current US$) in Nepal?
Your answer should be very brief. -2.27e+07. In the year 2009, what is the difference between the Aid flow (current US$) of Grenada and Aid flow (current US$) of Malaysia?
Your answer should be compact. 1.48e+07. In the year 2009, what is the difference between the Aid flow (current US$) of Grenada and Aid flow (current US$) of Nepal?
Ensure brevity in your answer.  -2.92e+07. In the year 2009, what is the difference between the Aid flow (current US$) in Malaysia and Aid flow (current US$) in Nepal?
Make the answer very short. -4.39e+07. In the year 2010, what is the difference between the Aid flow (current US$) in Argentina and Aid flow (current US$) in Grenada?
Offer a terse response. -4.21e+06. In the year 2010, what is the difference between the Aid flow (current US$) in Argentina and Aid flow (current US$) in Malaysia?
Provide a short and direct response. 6.75e+06. In the year 2010, what is the difference between the Aid flow (current US$) of Argentina and Aid flow (current US$) of Nepal?
Your response must be concise. -3.82e+07. In the year 2010, what is the difference between the Aid flow (current US$) of Grenada and Aid flow (current US$) of Malaysia?
Provide a short and direct response. 1.10e+07. In the year 2010, what is the difference between the Aid flow (current US$) in Grenada and Aid flow (current US$) in Nepal?
Provide a succinct answer. -3.40e+07. In the year 2010, what is the difference between the Aid flow (current US$) of Malaysia and Aid flow (current US$) of Nepal?
Your answer should be very brief. -4.50e+07. In the year 2011, what is the difference between the Aid flow (current US$) of Argentina and Aid flow (current US$) of Grenada?
Ensure brevity in your answer.  1.31e+07. In the year 2011, what is the difference between the Aid flow (current US$) in Argentina and Aid flow (current US$) in Malaysia?
Make the answer very short. 1.44e+07. In the year 2011, what is the difference between the Aid flow (current US$) in Argentina and Aid flow (current US$) in Nepal?
Offer a very short reply. -1.72e+07. In the year 2011, what is the difference between the Aid flow (current US$) of Grenada and Aid flow (current US$) of Malaysia?
Ensure brevity in your answer.  1.29e+06. In the year 2011, what is the difference between the Aid flow (current US$) of Grenada and Aid flow (current US$) of Nepal?
Offer a very short reply. -3.03e+07. In the year 2011, what is the difference between the Aid flow (current US$) of Malaysia and Aid flow (current US$) of Nepal?
Offer a very short reply. -3.16e+07. In the year 2012, what is the difference between the Aid flow (current US$) of Argentina and Aid flow (current US$) of Grenada?
Your response must be concise. 1.08e+08. In the year 2012, what is the difference between the Aid flow (current US$) of Argentina and Aid flow (current US$) of Malaysia?
Provide a short and direct response. 1.08e+08. In the year 2012, what is the difference between the Aid flow (current US$) in Argentina and Aid flow (current US$) in Nepal?
Provide a succinct answer. 8.16e+07. In the year 2012, what is the difference between the Aid flow (current US$) in Grenada and Aid flow (current US$) in Nepal?
Offer a very short reply. -2.67e+07. In the year 2012, what is the difference between the Aid flow (current US$) of Malaysia and Aid flow (current US$) of Nepal?
Your answer should be compact. -2.67e+07. In the year 2013, what is the difference between the Aid flow (current US$) in Grenada and Aid flow (current US$) in Malaysia?
Offer a very short reply. -2.47e+06. In the year 2013, what is the difference between the Aid flow (current US$) in Grenada and Aid flow (current US$) in Nepal?
Keep it short and to the point. -3.97e+07. In the year 2013, what is the difference between the Aid flow (current US$) of Malaysia and Aid flow (current US$) of Nepal?
Your response must be concise. -3.73e+07. What is the ratio of the Aid flow (current US$) of Argentina in 2006 to that in 2007?
Keep it short and to the point. 4.03. What is the ratio of the Aid flow (current US$) in Grenada in 2006 to that in 2007?
Provide a short and direct response. 3.95. What is the ratio of the Aid flow (current US$) in Malaysia in 2006 to that in 2007?
Offer a terse response. 3.58. What is the ratio of the Aid flow (current US$) of Nepal in 2006 to that in 2007?
Your response must be concise. 0.99. What is the ratio of the Aid flow (current US$) of Argentina in 2006 to that in 2008?
Provide a short and direct response. 1.48. What is the ratio of the Aid flow (current US$) of Grenada in 2006 to that in 2008?
Provide a succinct answer. 0.45. What is the ratio of the Aid flow (current US$) of Malaysia in 2006 to that in 2008?
Your answer should be very brief. 4.39. What is the ratio of the Aid flow (current US$) in Nepal in 2006 to that in 2008?
Your response must be concise. 0.53. What is the ratio of the Aid flow (current US$) in Argentina in 2006 to that in 2009?
Ensure brevity in your answer.  1.16. What is the ratio of the Aid flow (current US$) in Grenada in 2006 to that in 2009?
Your response must be concise. 0.3. What is the ratio of the Aid flow (current US$) of Malaysia in 2006 to that in 2009?
Your response must be concise. 27.2. What is the ratio of the Aid flow (current US$) of Nepal in 2006 to that in 2009?
Your answer should be very brief. 0.55. What is the ratio of the Aid flow (current US$) in Argentina in 2006 to that in 2010?
Provide a short and direct response. 3.09. What is the ratio of the Aid flow (current US$) in Grenada in 2006 to that in 2010?
Your answer should be compact. 0.36. What is the ratio of the Aid flow (current US$) of Malaysia in 2006 to that in 2010?
Offer a terse response. 1.12. What is the ratio of the Aid flow (current US$) in Nepal in 2006 to that in 2010?
Offer a terse response. 0.53. What is the ratio of the Aid flow (current US$) in Argentina in 2006 to that in 2011?
Your response must be concise. 1.55. What is the ratio of the Aid flow (current US$) of Grenada in 2006 to that in 2011?
Provide a succinct answer. 1.57. What is the ratio of the Aid flow (current US$) of Malaysia in 2006 to that in 2011?
Make the answer very short. 0.91. What is the ratio of the Aid flow (current US$) in Nepal in 2006 to that in 2011?
Offer a terse response. 0.74. What is the ratio of the Aid flow (current US$) in Argentina in 2006 to that in 2012?
Make the answer very short. 0.23. What is the ratio of the Aid flow (current US$) in Grenada in 2006 to that in 2012?
Your answer should be very brief. 5.47. What is the ratio of the Aid flow (current US$) in Malaysia in 2006 to that in 2012?
Provide a succinct answer. 1.81. What is the ratio of the Aid flow (current US$) in Nepal in 2006 to that in 2012?
Make the answer very short. 0.89. What is the ratio of the Aid flow (current US$) of Grenada in 2006 to that in 2013?
Make the answer very short. 12.88. What is the ratio of the Aid flow (current US$) in Malaysia in 2006 to that in 2013?
Give a very brief answer. 0.48. What is the ratio of the Aid flow (current US$) in Nepal in 2006 to that in 2013?
Keep it short and to the point. 0.61. What is the ratio of the Aid flow (current US$) of Argentina in 2007 to that in 2008?
Keep it short and to the point. 0.37. What is the ratio of the Aid flow (current US$) in Grenada in 2007 to that in 2008?
Your answer should be very brief. 0.12. What is the ratio of the Aid flow (current US$) of Malaysia in 2007 to that in 2008?
Keep it short and to the point. 1.23. What is the ratio of the Aid flow (current US$) of Nepal in 2007 to that in 2008?
Ensure brevity in your answer.  0.54. What is the ratio of the Aid flow (current US$) in Argentina in 2007 to that in 2009?
Provide a succinct answer. 0.29. What is the ratio of the Aid flow (current US$) in Grenada in 2007 to that in 2009?
Ensure brevity in your answer.  0.07. What is the ratio of the Aid flow (current US$) of Nepal in 2007 to that in 2009?
Provide a succinct answer. 0.56. What is the ratio of the Aid flow (current US$) of Argentina in 2007 to that in 2010?
Provide a succinct answer. 0.77. What is the ratio of the Aid flow (current US$) of Grenada in 2007 to that in 2010?
Your response must be concise. 0.09. What is the ratio of the Aid flow (current US$) in Malaysia in 2007 to that in 2010?
Your response must be concise. 0.31. What is the ratio of the Aid flow (current US$) in Nepal in 2007 to that in 2010?
Offer a terse response. 0.54. What is the ratio of the Aid flow (current US$) in Argentina in 2007 to that in 2011?
Offer a terse response. 0.38. What is the ratio of the Aid flow (current US$) in Grenada in 2007 to that in 2011?
Ensure brevity in your answer.  0.4. What is the ratio of the Aid flow (current US$) in Malaysia in 2007 to that in 2011?
Offer a very short reply. 0.25. What is the ratio of the Aid flow (current US$) of Nepal in 2007 to that in 2011?
Offer a very short reply. 0.75. What is the ratio of the Aid flow (current US$) of Argentina in 2007 to that in 2012?
Offer a very short reply. 0.06. What is the ratio of the Aid flow (current US$) of Grenada in 2007 to that in 2012?
Give a very brief answer. 1.39. What is the ratio of the Aid flow (current US$) in Malaysia in 2007 to that in 2012?
Keep it short and to the point. 0.51. What is the ratio of the Aid flow (current US$) in Nepal in 2007 to that in 2012?
Keep it short and to the point. 0.9. What is the ratio of the Aid flow (current US$) in Grenada in 2007 to that in 2013?
Your response must be concise. 3.26. What is the ratio of the Aid flow (current US$) in Malaysia in 2007 to that in 2013?
Your answer should be very brief. 0.14. What is the ratio of the Aid flow (current US$) of Nepal in 2007 to that in 2013?
Your response must be concise. 0.62. What is the ratio of the Aid flow (current US$) of Argentina in 2008 to that in 2009?
Provide a short and direct response. 0.78. What is the ratio of the Aid flow (current US$) of Grenada in 2008 to that in 2009?
Provide a short and direct response. 0.65. What is the ratio of the Aid flow (current US$) in Nepal in 2008 to that in 2009?
Provide a short and direct response. 1.05. What is the ratio of the Aid flow (current US$) in Argentina in 2008 to that in 2010?
Make the answer very short. 2.09. What is the ratio of the Aid flow (current US$) in Grenada in 2008 to that in 2010?
Ensure brevity in your answer.  0.79. What is the ratio of the Aid flow (current US$) in Malaysia in 2008 to that in 2010?
Provide a short and direct response. 0.26. What is the ratio of the Aid flow (current US$) in Argentina in 2008 to that in 2011?
Ensure brevity in your answer.  1.05. What is the ratio of the Aid flow (current US$) of Grenada in 2008 to that in 2011?
Provide a succinct answer. 3.45. What is the ratio of the Aid flow (current US$) in Malaysia in 2008 to that in 2011?
Give a very brief answer. 0.21. What is the ratio of the Aid flow (current US$) in Nepal in 2008 to that in 2011?
Offer a terse response. 1.39. What is the ratio of the Aid flow (current US$) of Argentina in 2008 to that in 2012?
Make the answer very short. 0.15. What is the ratio of the Aid flow (current US$) in Grenada in 2008 to that in 2012?
Offer a very short reply. 12.04. What is the ratio of the Aid flow (current US$) in Malaysia in 2008 to that in 2012?
Your answer should be very brief. 0.41. What is the ratio of the Aid flow (current US$) in Nepal in 2008 to that in 2012?
Provide a short and direct response. 1.68. What is the ratio of the Aid flow (current US$) of Grenada in 2008 to that in 2013?
Your answer should be very brief. 28.32. What is the ratio of the Aid flow (current US$) of Malaysia in 2008 to that in 2013?
Make the answer very short. 0.11. What is the ratio of the Aid flow (current US$) of Nepal in 2008 to that in 2013?
Keep it short and to the point. 1.15. What is the ratio of the Aid flow (current US$) of Argentina in 2009 to that in 2010?
Ensure brevity in your answer.  2.67. What is the ratio of the Aid flow (current US$) of Grenada in 2009 to that in 2010?
Ensure brevity in your answer.  1.22. What is the ratio of the Aid flow (current US$) of Malaysia in 2009 to that in 2010?
Ensure brevity in your answer.  0.04. What is the ratio of the Aid flow (current US$) in Nepal in 2009 to that in 2010?
Give a very brief answer. 0.95. What is the ratio of the Aid flow (current US$) of Argentina in 2009 to that in 2011?
Ensure brevity in your answer.  1.34. What is the ratio of the Aid flow (current US$) in Grenada in 2009 to that in 2011?
Keep it short and to the point. 5.3. What is the ratio of the Aid flow (current US$) in Malaysia in 2009 to that in 2011?
Make the answer very short. 0.03. What is the ratio of the Aid flow (current US$) in Nepal in 2009 to that in 2011?
Make the answer very short. 1.33. What is the ratio of the Aid flow (current US$) in Argentina in 2009 to that in 2012?
Give a very brief answer. 0.2. What is the ratio of the Aid flow (current US$) in Grenada in 2009 to that in 2012?
Provide a short and direct response. 18.5. What is the ratio of the Aid flow (current US$) of Malaysia in 2009 to that in 2012?
Provide a short and direct response. 0.07. What is the ratio of the Aid flow (current US$) of Nepal in 2009 to that in 2012?
Ensure brevity in your answer.  1.6. What is the ratio of the Aid flow (current US$) of Grenada in 2009 to that in 2013?
Make the answer very short. 43.53. What is the ratio of the Aid flow (current US$) in Malaysia in 2009 to that in 2013?
Give a very brief answer. 0.02. What is the ratio of the Aid flow (current US$) of Nepal in 2009 to that in 2013?
Offer a very short reply. 1.1. What is the ratio of the Aid flow (current US$) in Argentina in 2010 to that in 2011?
Offer a terse response. 0.5. What is the ratio of the Aid flow (current US$) of Grenada in 2010 to that in 2011?
Your answer should be compact. 4.36. What is the ratio of the Aid flow (current US$) of Malaysia in 2010 to that in 2011?
Provide a short and direct response. 0.81. What is the ratio of the Aid flow (current US$) in Nepal in 2010 to that in 2011?
Your answer should be very brief. 1.39. What is the ratio of the Aid flow (current US$) in Argentina in 2010 to that in 2012?
Offer a very short reply. 0.07. What is the ratio of the Aid flow (current US$) of Grenada in 2010 to that in 2012?
Make the answer very short. 15.21. What is the ratio of the Aid flow (current US$) of Malaysia in 2010 to that in 2012?
Ensure brevity in your answer.  1.61. What is the ratio of the Aid flow (current US$) of Nepal in 2010 to that in 2012?
Provide a short and direct response. 1.68. What is the ratio of the Aid flow (current US$) of Grenada in 2010 to that in 2013?
Provide a short and direct response. 35.79. What is the ratio of the Aid flow (current US$) in Malaysia in 2010 to that in 2013?
Offer a terse response. 0.43. What is the ratio of the Aid flow (current US$) of Nepal in 2010 to that in 2013?
Your answer should be very brief. 1.15. What is the ratio of the Aid flow (current US$) of Argentina in 2011 to that in 2012?
Provide a succinct answer. 0.15. What is the ratio of the Aid flow (current US$) in Grenada in 2011 to that in 2012?
Give a very brief answer. 3.49. What is the ratio of the Aid flow (current US$) in Malaysia in 2011 to that in 2012?
Offer a very short reply. 2. What is the ratio of the Aid flow (current US$) of Nepal in 2011 to that in 2012?
Provide a short and direct response. 1.2. What is the ratio of the Aid flow (current US$) in Grenada in 2011 to that in 2013?
Keep it short and to the point. 8.21. What is the ratio of the Aid flow (current US$) in Malaysia in 2011 to that in 2013?
Ensure brevity in your answer.  0.53. What is the ratio of the Aid flow (current US$) of Nepal in 2011 to that in 2013?
Your answer should be very brief. 0.83. What is the ratio of the Aid flow (current US$) of Grenada in 2012 to that in 2013?
Give a very brief answer. 2.35. What is the ratio of the Aid flow (current US$) in Malaysia in 2012 to that in 2013?
Your answer should be very brief. 0.27. What is the ratio of the Aid flow (current US$) of Nepal in 2012 to that in 2013?
Your response must be concise. 0.69. What is the difference between the highest and the second highest Aid flow (current US$) of Argentina?
Your answer should be very brief. 8.45e+07. What is the difference between the highest and the second highest Aid flow (current US$) of Grenada?
Ensure brevity in your answer.  2.63e+06. What is the difference between the highest and the second highest Aid flow (current US$) in Malaysia?
Offer a terse response. 1.31e+06. What is the difference between the highest and the second highest Aid flow (current US$) in Nepal?
Ensure brevity in your answer.  0. What is the difference between the highest and the lowest Aid flow (current US$) of Argentina?
Offer a very short reply. 1.09e+08. What is the difference between the highest and the lowest Aid flow (current US$) of Grenada?
Offer a very short reply. 1.45e+07. What is the difference between the highest and the lowest Aid flow (current US$) in Malaysia?
Provide a succinct answer. 2.76e+06. What is the difference between the highest and the lowest Aid flow (current US$) of Nepal?
Your answer should be compact. 2.18e+07. 